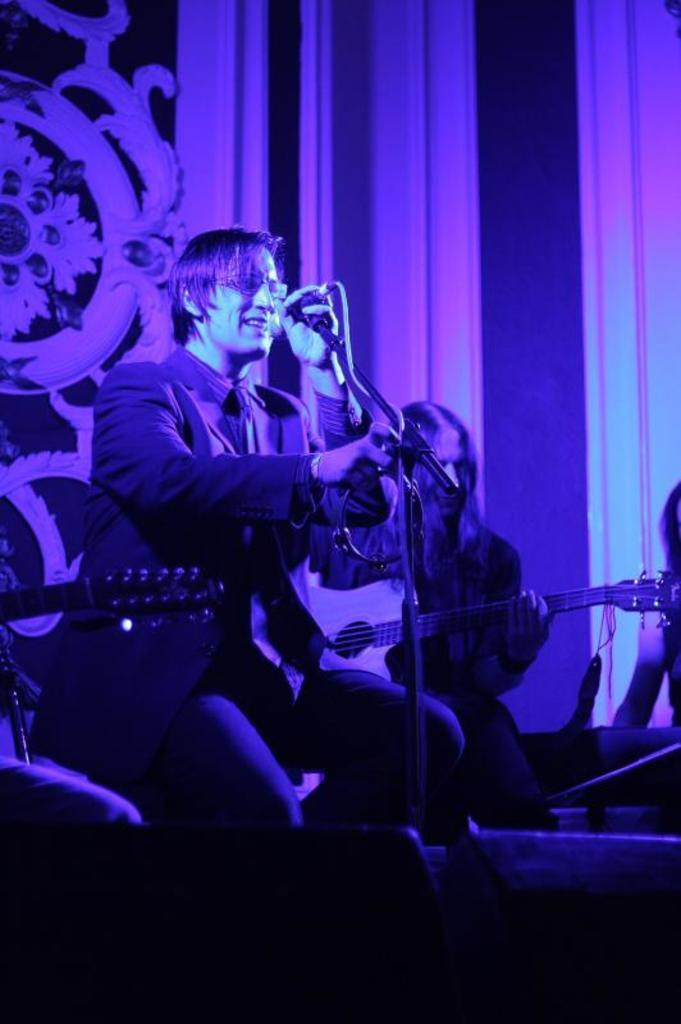What is the person in the image doing with the microphone? The person is holding a microphone in the image. What activity is the person with the microphone engaged in? The person is singing. What is the other person in the image doing? The other person is playing a musical instrument. How would you describe the color scheme of the background in the image? The background of the image has a pinkish and blue color. What caused the band to fold in the image? There is no band present in the image, and therefore no folding can be observed. 